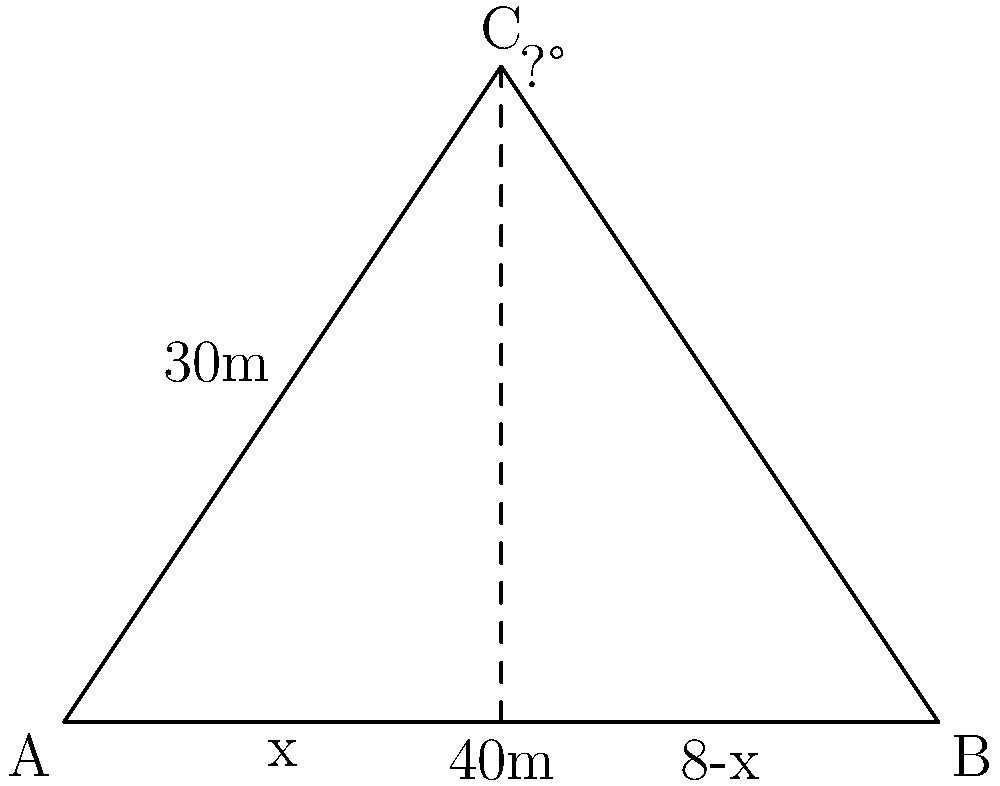As a paparazzo, you're trying to capture a celebrity from a hidden position. Given the diagram, where A is your position, B is the celebrity's location, and C is the optimal shooting point, calculate the angle (in degrees) at point C for the best telephoto lens shot. The distance AB is 40m, and AC is 30m. To find the angle at C, we'll use the law of cosines. Let's approach this step-by-step:

1) First, we need to find the length of BC. We can do this using the Pythagorean theorem:
   $BC^2 = AB^2 + AC^2 - 2(AB)(AC)\cos(C)$

2) We know:
   $AB = 40m$
   $AC = 30m$
   We need to find angle C

3) Rearranging the law of cosines:
   $\cos(C) = \frac{AB^2 + AC^2 - BC^2}{2(AB)(AC)}$

4) We can find BC using the Pythagorean theorem:
   $BC^2 = 40^2 + 30^2 = 1600 + 900 = 2500$
   $BC = \sqrt{2500} = 50m$

5) Now we can plug everything into our formula:
   $\cos(C) = \frac{40^2 + 30^2 - 50^2}{2(40)(30)}$
   $= \frac{1600 + 900 - 2500}{2400}$
   $= \frac{0}{2400} = 0$

6) Therefore, $C = \arccos(0) = 90°$

This makes sense geometrically, as the triangle appears to be a right triangle with C as the right angle.
Answer: 90° 